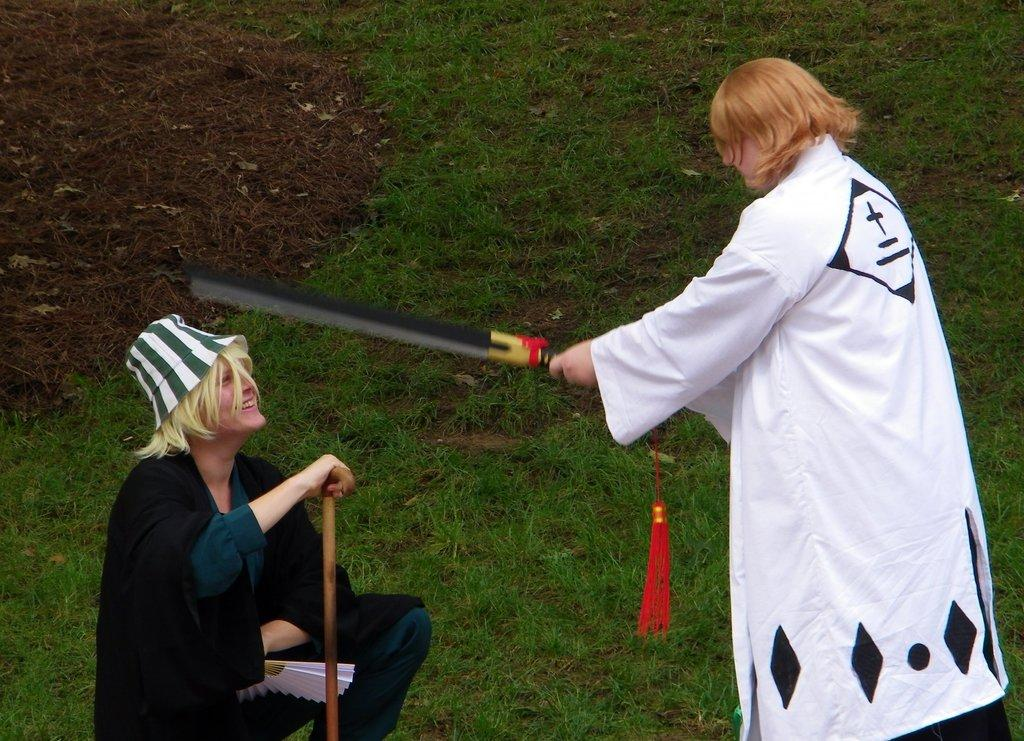How many people are present in the image? There are two people in the image. What are the people holding in their hands? The people are holding sticks in their hands. What type of surface is visible at the bottom of the image? There is grass on the surface at the bottom of the image. Where is the basin located in the image? There is no basin present in the image. What type of animal is sitting on the arm of one of the people in the image? There are no animals present in the image, including a toad. 